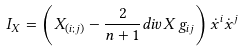Convert formula to latex. <formula><loc_0><loc_0><loc_500><loc_500>I _ { X } = \left ( X _ { ( i ; j ) } - \frac { 2 } { n + 1 } d i v X \, g _ { i j } \right ) \dot { x } ^ { i } \dot { x } ^ { j }</formula> 